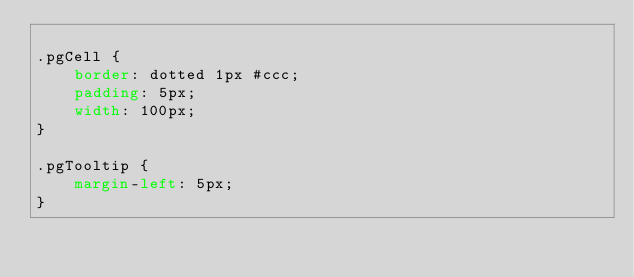Convert code to text. <code><loc_0><loc_0><loc_500><loc_500><_CSS_>
.pgCell {
    border: dotted 1px #ccc;
    padding: 5px;
    width: 100px;
}

.pgTooltip {
    margin-left: 5px;
}</code> 